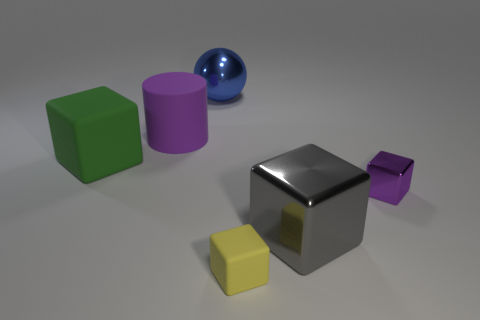There is a purple object that is made of the same material as the yellow thing; what shape is it?
Provide a succinct answer. Cylinder. What number of other objects are there of the same shape as the big green object?
Make the answer very short. 3. There is a small yellow matte block; how many shiny objects are to the right of it?
Provide a short and direct response. 2. There is a purple thing that is behind the purple metallic thing; does it have the same size as the metallic thing to the right of the gray cube?
Ensure brevity in your answer.  No. How many other objects are the same size as the green cube?
Offer a terse response. 3. What is the large block that is on the right side of the cube left of the matte object behind the big green matte thing made of?
Your answer should be compact. Metal. There is a metallic sphere; is its size the same as the gray metallic object that is behind the tiny yellow thing?
Make the answer very short. Yes. There is a object that is to the left of the gray block and on the right side of the large sphere; what size is it?
Your response must be concise. Small. Is there a small metallic cube of the same color as the big ball?
Keep it short and to the point. No. The rubber block left of the matte block that is on the right side of the big blue ball is what color?
Your answer should be compact. Green. 